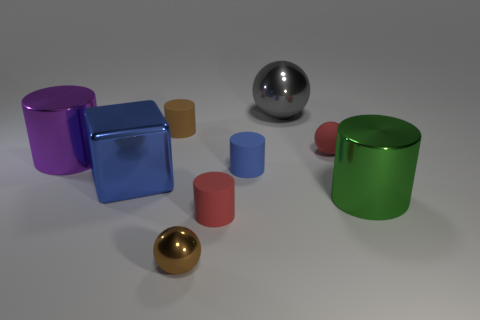Subtract all gray metallic spheres. How many spheres are left? 2 Subtract all blue cylinders. How many cylinders are left? 4 Subtract all blocks. How many objects are left? 8 Subtract 1 blue cylinders. How many objects are left? 8 Subtract 3 cylinders. How many cylinders are left? 2 Subtract all gray cubes. Subtract all yellow cylinders. How many cubes are left? 1 Subtract all yellow spheres. How many purple cylinders are left? 1 Subtract all blocks. Subtract all large shiny blocks. How many objects are left? 7 Add 5 gray spheres. How many gray spheres are left? 6 Add 2 big red objects. How many big red objects exist? 2 